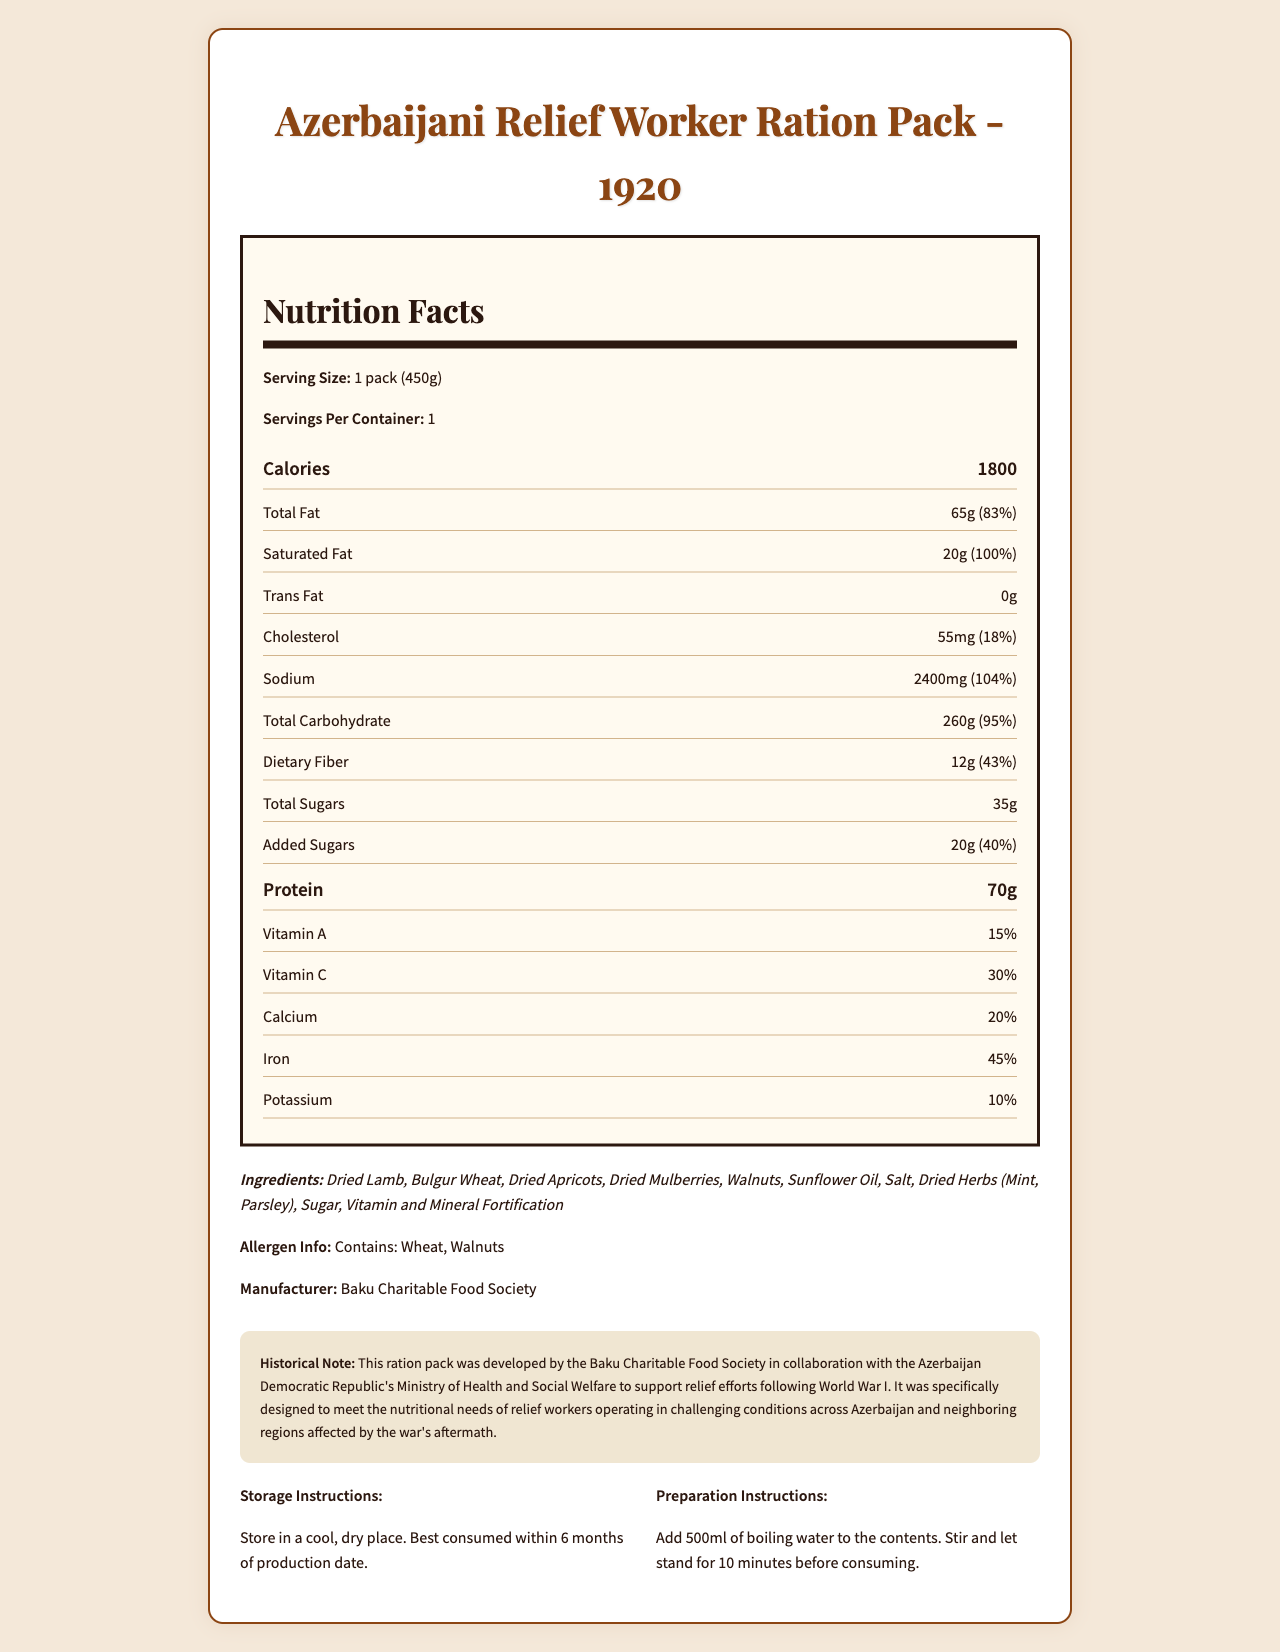who manufactured this ration pack? The document states, “Manufacturer: Baku Charitable Food Society.”
Answer: Baku Charitable Food Society what is the serving size of the ration pack? The serving size is mentioned as "1 pack (450g)" in the document.
Answer: 1 pack (450g) how many calories are in one serving? The calories per serving is listed as "1800" in the document.
Answer: 1800 what are the main ingredients in the ration pack? The main ingredients are mentioned in the ingredients list.
Answer: Dried Lamb, Bulgur Wheat, Dried Apricots, Dried Mulberries, Walnuts, Sunflower Oil, Salt, Dried Herbs (Mint, Parsley), Sugar, Vitamin and Mineral Fortification how much protein does the ration pack contain? The document states that the protein content is "70g".
Answer: 70g how much sodium is in one serving of the ration pack? The document lists the sodium content as "2400mg".
Answer: 2400mg which vitamin is highest in daily value percentage? A. Vitamin A B. Vitamin C C. Calcium D. Iron The iron has the highest daily value percentage at 45%, as noted in the document.
Answer: D. Iron which item contains the most fat? A. Trans Fat B. Saturated Fat C. Total Fat Total fat is listed as "65g" compared to "20g" for saturated fat and "0g" for trans fat.
Answer: C. Total Fat does the ration pack contain any allergens? The document states, "Contains: Wheat, Walnuts," indicating the presence of allergens.
Answer: Yes how should the ration pack be stored? The storage instructions specify this exact method.
Answer: Store in a cool, dry place. Best consumed within 6 months of production date. describe the purpose and historical context of this ration pack The historical note section of the document provides this information.
Answer: The ration pack was developed by the Baku Charitable Food Society in collaboration with the Azerbaijan Democratic Republic's Ministry of Health and Social Welfare to support relief efforts following World War I. It was designed to meet the nutritional needs of relief workers operating under challenging conditions across Azerbaijan and neighboring regions affected by the war's aftermath. how should the ration pack be prepared for consumption? The preparation instructions provide these steps clearly.
Answer: Add 500ml of boiling water to the contents. Stir and let stand for 10 minutes before consuming. what is the daily value percentage of dietary fiber in the ration pack? The dietary fiber is listed as "43%" of the daily value.
Answer: 43% which ingredient is not listed in the nutrition label? A. Dried Lamb B. Salt C. Chicken D. Bulgur Wheat Chicken is not listed among the ingredients; the document mentions "Dried Lamb, Bulgur Wheat, Dried Apricots, Dried Mulberries, Walnuts, Sunflower Oil, Salt, Dried Herbs (Mint, Parsley), Sugar, Vitamin and Mineral Fortification."
Answer: C. Chicken does the ration pack contain trans fat? The document lists trans fat as "0g", indicating that it does not contain any trans fat.
Answer: No can the expiration date of the ration pack be determined from the document? The document advises consumption within 6 months of production but does not provide a production or expiration date, so it cannot be determined.
Answer: Cannot be determined 